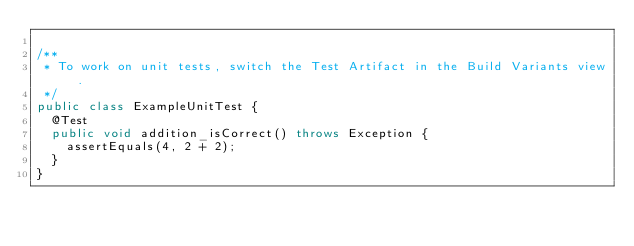Convert code to text. <code><loc_0><loc_0><loc_500><loc_500><_Java_>
/**
 * To work on unit tests, switch the Test Artifact in the Build Variants view.
 */
public class ExampleUnitTest {
	@Test
	public void addition_isCorrect() throws Exception {
		assertEquals(4, 2 + 2);
	}
}</code> 